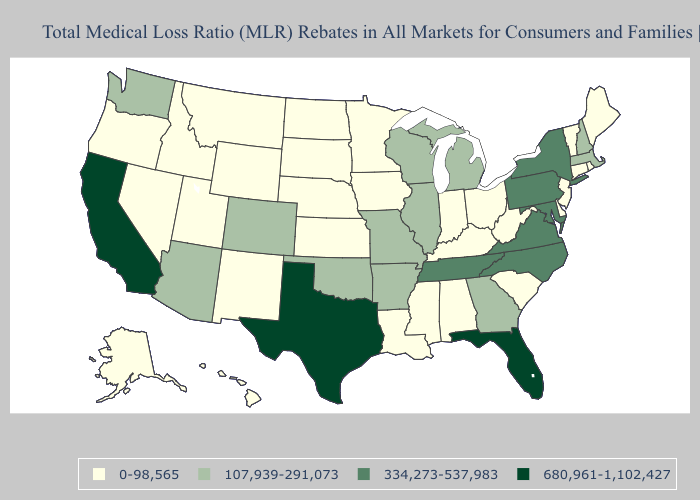What is the value of Louisiana?
Be succinct. 0-98,565. Does New York have the lowest value in the USA?
Concise answer only. No. Which states have the highest value in the USA?
Write a very short answer. California, Florida, Texas. Which states have the highest value in the USA?
Give a very brief answer. California, Florida, Texas. What is the lowest value in states that border North Carolina?
Short answer required. 0-98,565. What is the highest value in the USA?
Give a very brief answer. 680,961-1,102,427. Which states hav the highest value in the Northeast?
Write a very short answer. New York, Pennsylvania. What is the value of Louisiana?
Concise answer only. 0-98,565. Among the states that border New Jersey , which have the lowest value?
Short answer required. Delaware. Which states have the highest value in the USA?
Short answer required. California, Florida, Texas. Among the states that border Colorado , does Oklahoma have the highest value?
Quick response, please. Yes. What is the highest value in states that border Nevada?
Be succinct. 680,961-1,102,427. How many symbols are there in the legend?
Keep it brief. 4. Among the states that border Vermont , which have the lowest value?
Short answer required. Massachusetts, New Hampshire. Name the states that have a value in the range 680,961-1,102,427?
Quick response, please. California, Florida, Texas. 